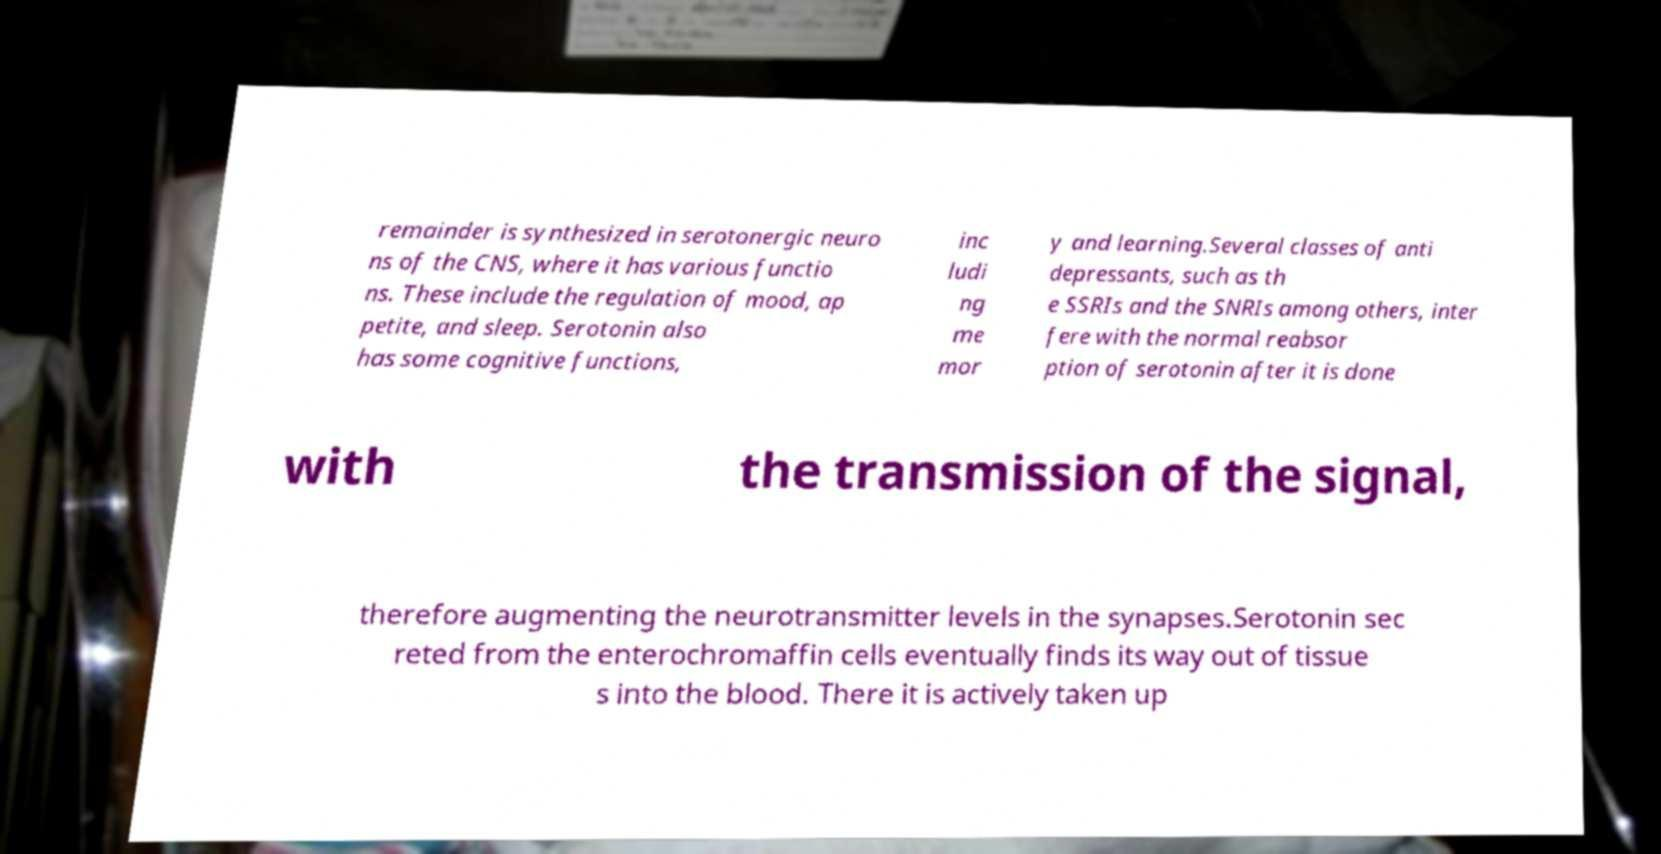Please identify and transcribe the text found in this image. remainder is synthesized in serotonergic neuro ns of the CNS, where it has various functio ns. These include the regulation of mood, ap petite, and sleep. Serotonin also has some cognitive functions, inc ludi ng me mor y and learning.Several classes of anti depressants, such as th e SSRIs and the SNRIs among others, inter fere with the normal reabsor ption of serotonin after it is done with the transmission of the signal, therefore augmenting the neurotransmitter levels in the synapses.Serotonin sec reted from the enterochromaffin cells eventually finds its way out of tissue s into the blood. There it is actively taken up 